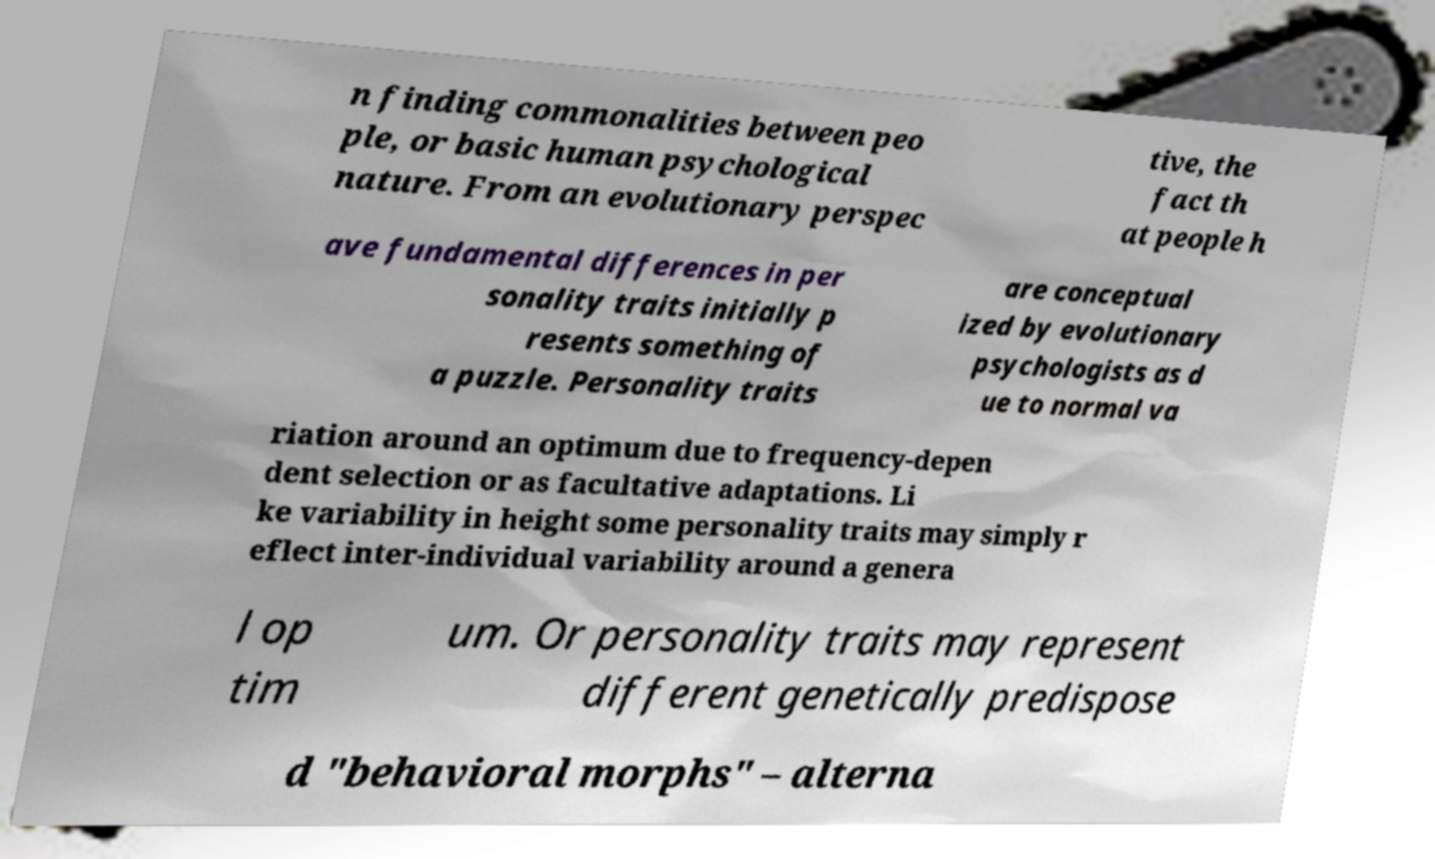For documentation purposes, I need the text within this image transcribed. Could you provide that? n finding commonalities between peo ple, or basic human psychological nature. From an evolutionary perspec tive, the fact th at people h ave fundamental differences in per sonality traits initially p resents something of a puzzle. Personality traits are conceptual ized by evolutionary psychologists as d ue to normal va riation around an optimum due to frequency-depen dent selection or as facultative adaptations. Li ke variability in height some personality traits may simply r eflect inter-individual variability around a genera l op tim um. Or personality traits may represent different genetically predispose d "behavioral morphs" – alterna 